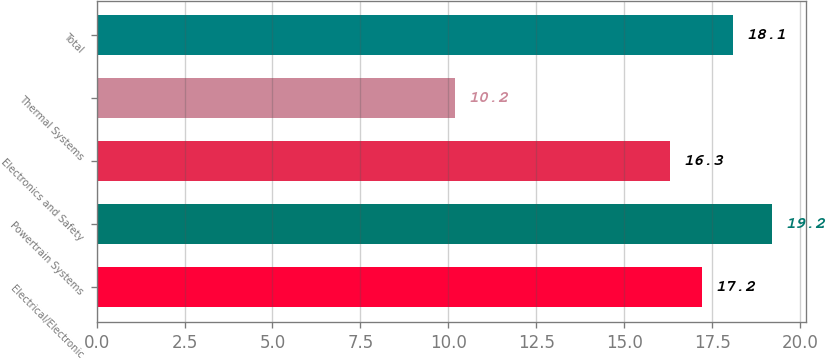Convert chart. <chart><loc_0><loc_0><loc_500><loc_500><bar_chart><fcel>Electrical/Electronic<fcel>Powertrain Systems<fcel>Electronics and Safety<fcel>Thermal Systems<fcel>Total<nl><fcel>17.2<fcel>19.2<fcel>16.3<fcel>10.2<fcel>18.1<nl></chart> 